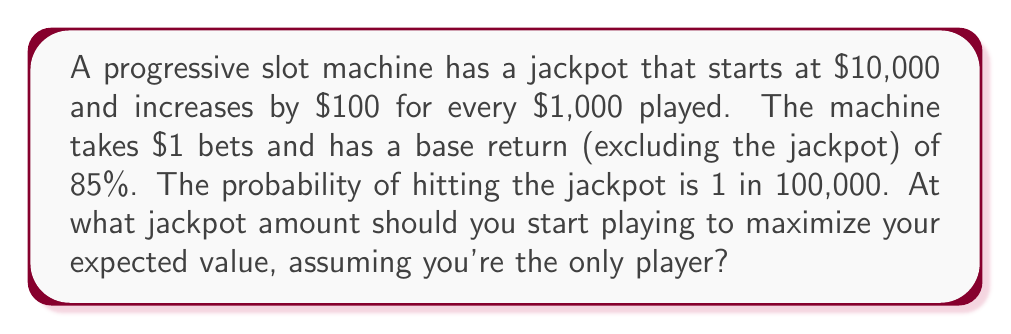Help me with this question. Let's approach this step-by-step:

1) First, we need to express the jackpot as a function of the number of bets made:
   $$J(n) = 10000 + 100 \cdot \frac{n}{1000} = 10000 + 0.1n$$
   where $n$ is the number of bets made since the jackpot was last hit.

2) The expected value (EV) of a single bet consists of:
   a) The base return: $0.85
   b) The probability of hitting the jackpot multiplied by the jackpot amount:
      $$\frac{1}{100000} \cdot (10000 + 0.1n)$$

3) Therefore, the EV of a single bet is:
   $$EV(n) = 0.85 + \frac{1}{100000} \cdot (10000 + 0.1n) - 1$$
   The -1 at the end represents the cost of the bet.

4) To find the break-even point, we set $EV(n) = 0$:
   $$0.85 + \frac{1}{100000} \cdot (10000 + 0.1n) - 1 = 0$$

5) Solving for $n$:
   $$\frac{1}{100000} \cdot (10000 + 0.1n) = 0.15$$
   $$10000 + 0.1n = 15000$$
   $$0.1n = 5000$$
   $$n = 50000$$

6) This means the break-even point occurs after 50,000 bets. To find the corresponding jackpot amount:
   $$J(50000) = 10000 + 0.1 \cdot 50000 = 15000$$

Therefore, you should start playing when the jackpot reaches $15,000 to have a positive expected value.
Answer: $15,000 